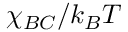Convert formula to latex. <formula><loc_0><loc_0><loc_500><loc_500>\chi _ { B C } / k _ { B } T</formula> 